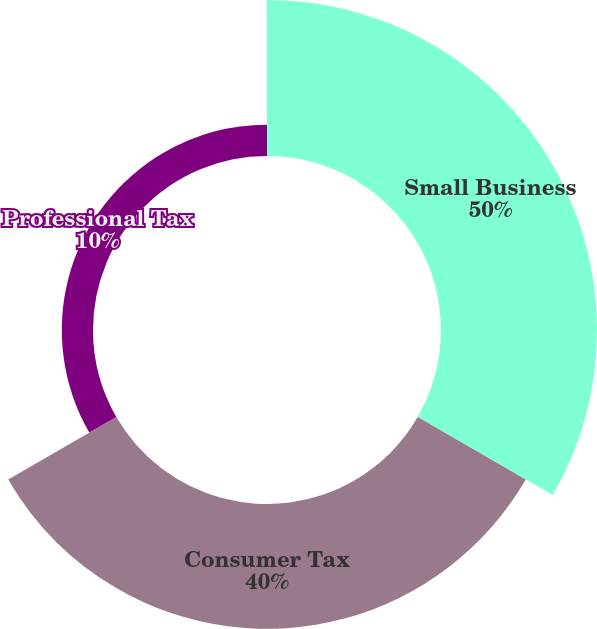<chart> <loc_0><loc_0><loc_500><loc_500><pie_chart><fcel>Small Business<fcel>Consumer Tax<fcel>Professional Tax<nl><fcel>50.0%<fcel>40.0%<fcel>10.0%<nl></chart> 